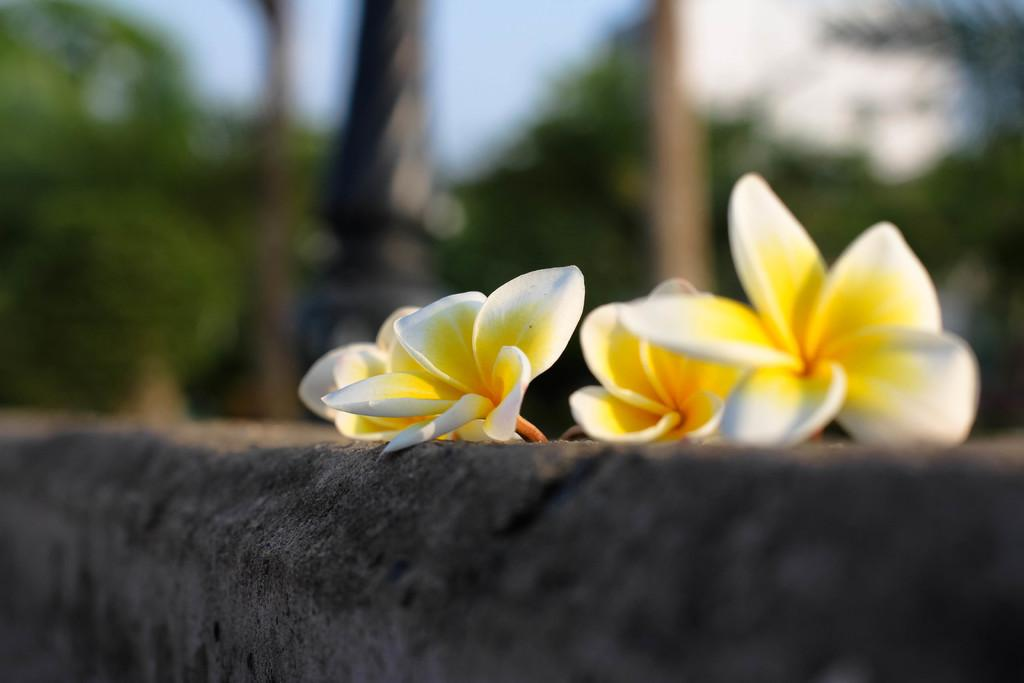What is on the wall in the image? There are flowers on a wall in the image. What other structures can be seen in the image? Poles are visible in the image. What type of natural elements are present in the image? Trees and plants are present in the image. How are the elements mentioned in points 2-4 depicted in the image? The elements mentioned in points 2-4 are in a blurred manner. What type of butter is being used to decorate the flowers in the image? There is no butter present in the image; it features flowers on a wall, poles, trees, and plants. Can you tell me how many girls are visible in the image? There are no girls present in the image. 